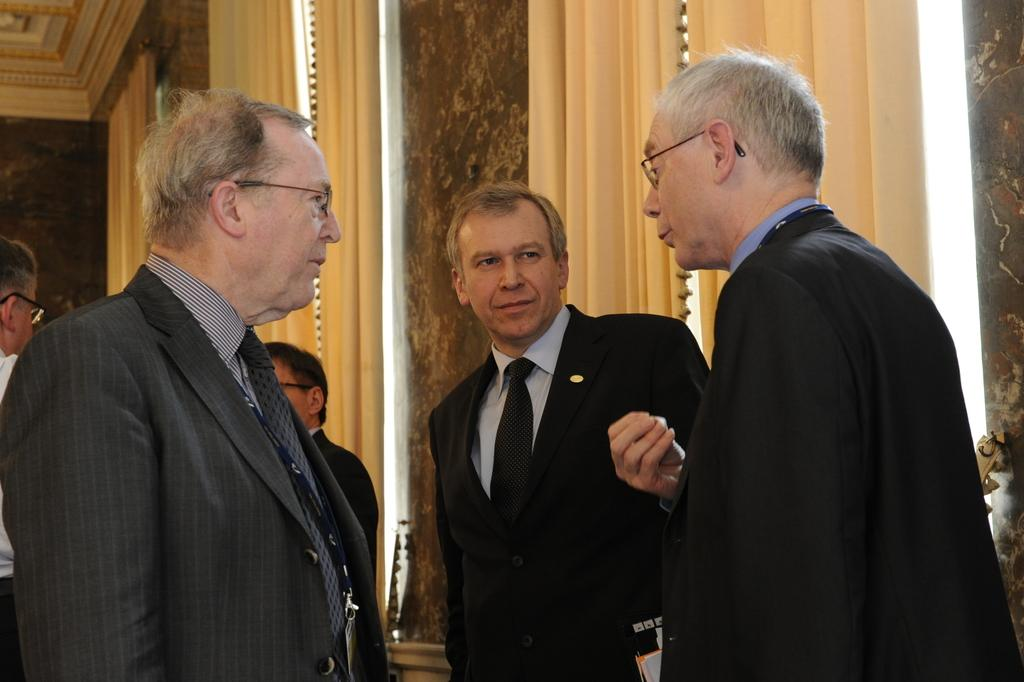How many people are present in the image? There are persons in the image, but the exact number cannot be determined from the provided facts. What can be seen in the background of the image? In the background of the image, there are curtains, pillars, and a wall. What type of architectural feature is present in the background of the image? Pillars are present in the background of the image. What type of plant is growing on the person's finger in the image? There is no plant growing on a person's finger in the image. 